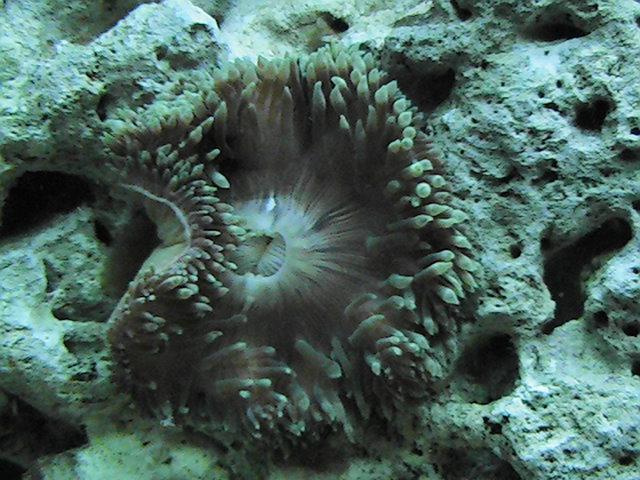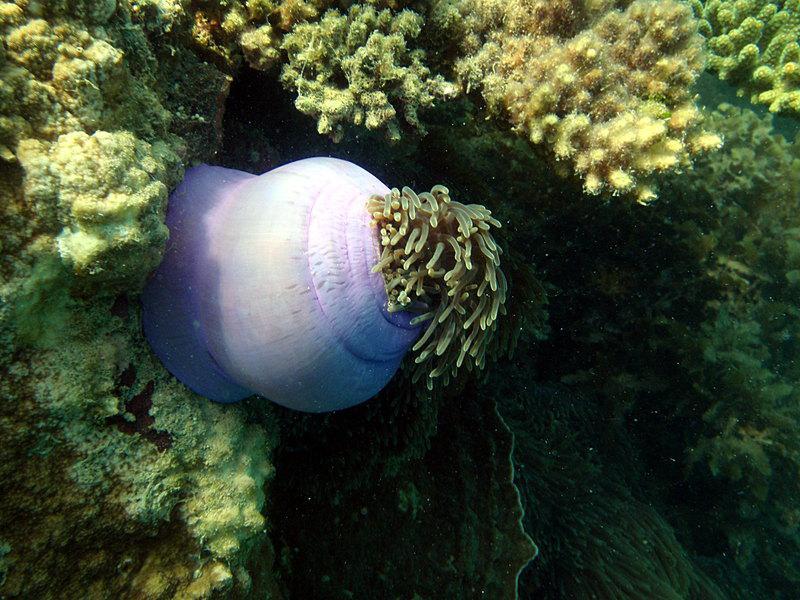The first image is the image on the left, the second image is the image on the right. For the images shown, is this caption "Some elements of the coral are pink in at least one of the images." true? Answer yes or no. No. The first image is the image on the left, the second image is the image on the right. Analyze the images presented: Is the assertion "An image shows brownish anemone tendrils emerging from a rounded, inflated looking purplish sac." valid? Answer yes or no. Yes. 